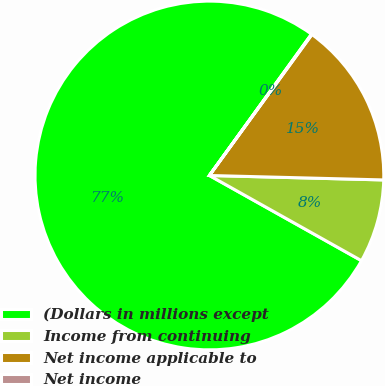Convert chart to OTSL. <chart><loc_0><loc_0><loc_500><loc_500><pie_chart><fcel>(Dollars in millions except<fcel>Income from continuing<fcel>Net income applicable to<fcel>Net income<nl><fcel>76.83%<fcel>7.72%<fcel>15.4%<fcel>0.05%<nl></chart> 